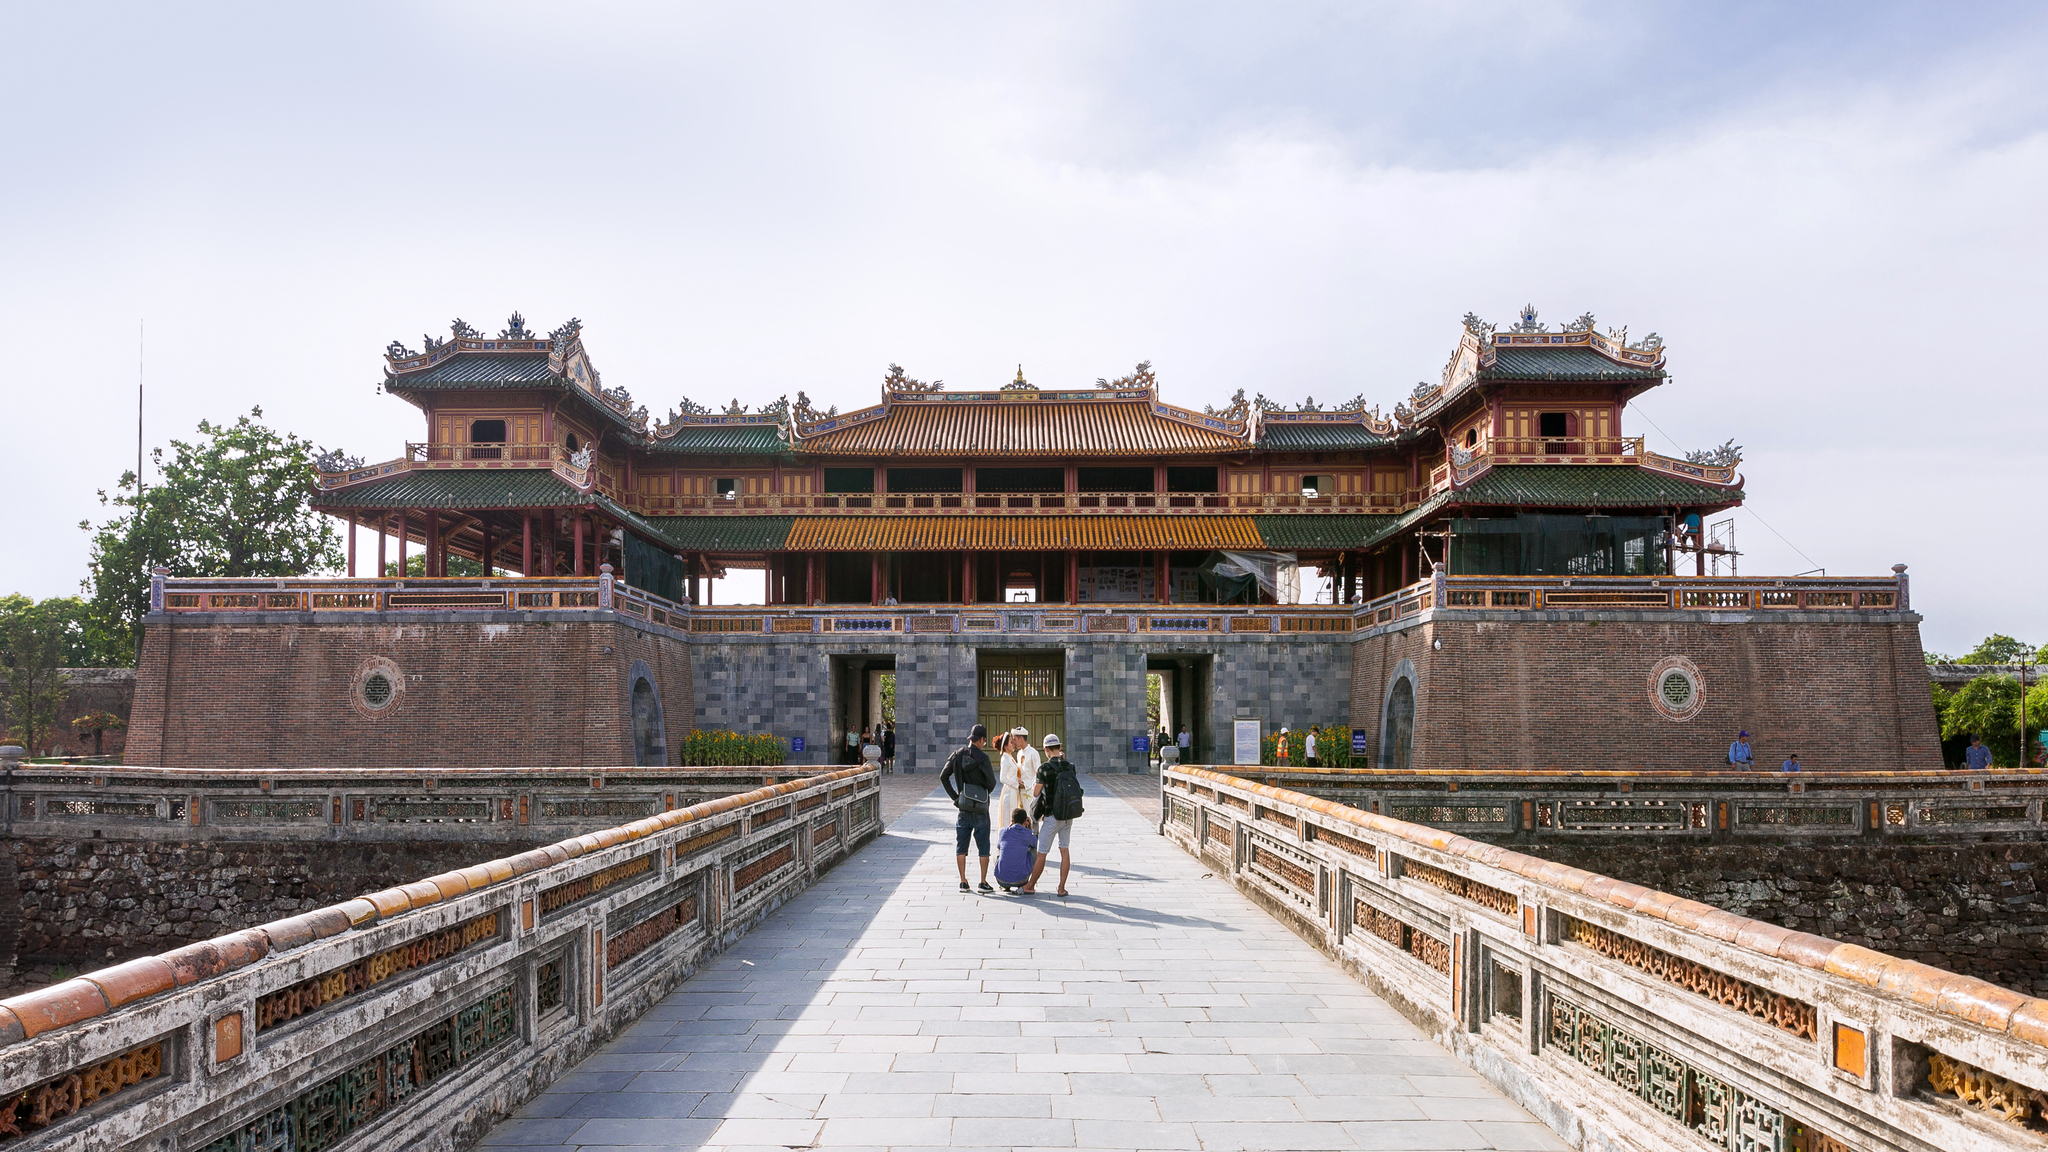Analyze the image in a comprehensive and detailed manner. The image captures the grandeur of the Imperial Citadel in Hue, Vietnam, showcasing the historical and architectural significance of this landmark. The structure stands proudly under a clear blue sky with a blend of intricate designs that highlight the architectural expertise of its era. The predominant use of red and gold hues gives the monument a regal appearance, while the green and blue tones add a harmonious contrast to the overall palette. The elevated perspective of the photograph allows for a comprehensive view of the citadel, making it possible to appreciate its multiple levels and architectural details. In the foreground, the blurred figures of visitors contribute a sense of scale to the impressive structure, indicating its vastness. The lush greenery in the background adds to the picturesque quality of the scene, enhancing the visual appeal. Through this image, one can truly appreciate the essence and beauty of the Imperial Citadel, a cherished symbol of Vietnam's rich heritage. 